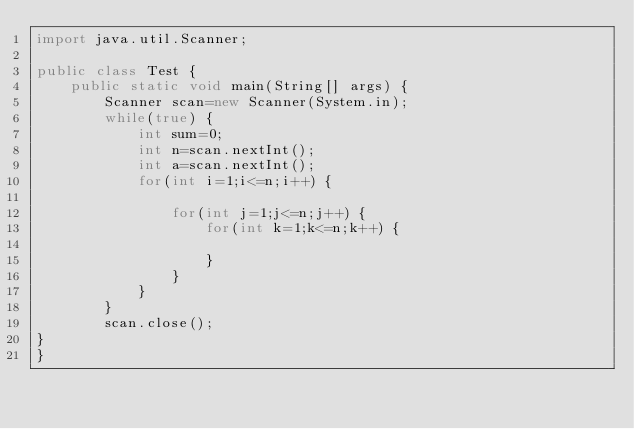Convert code to text. <code><loc_0><loc_0><loc_500><loc_500><_Java_>import java.util.Scanner;

public class Test {
	public static void main(String[] args) {
		Scanner scan=new Scanner(System.in);
		while(true) {
			int sum=0;
			int n=scan.nextInt();
			int a=scan.nextInt();
			for(int i=1;i<=n;i++) {
				
				for(int j=1;j<=n;j++) {
					for(int k=1;k<=n;k++) {
						
					}
				}
			}
		}
		scan.close();
}
}
</code> 